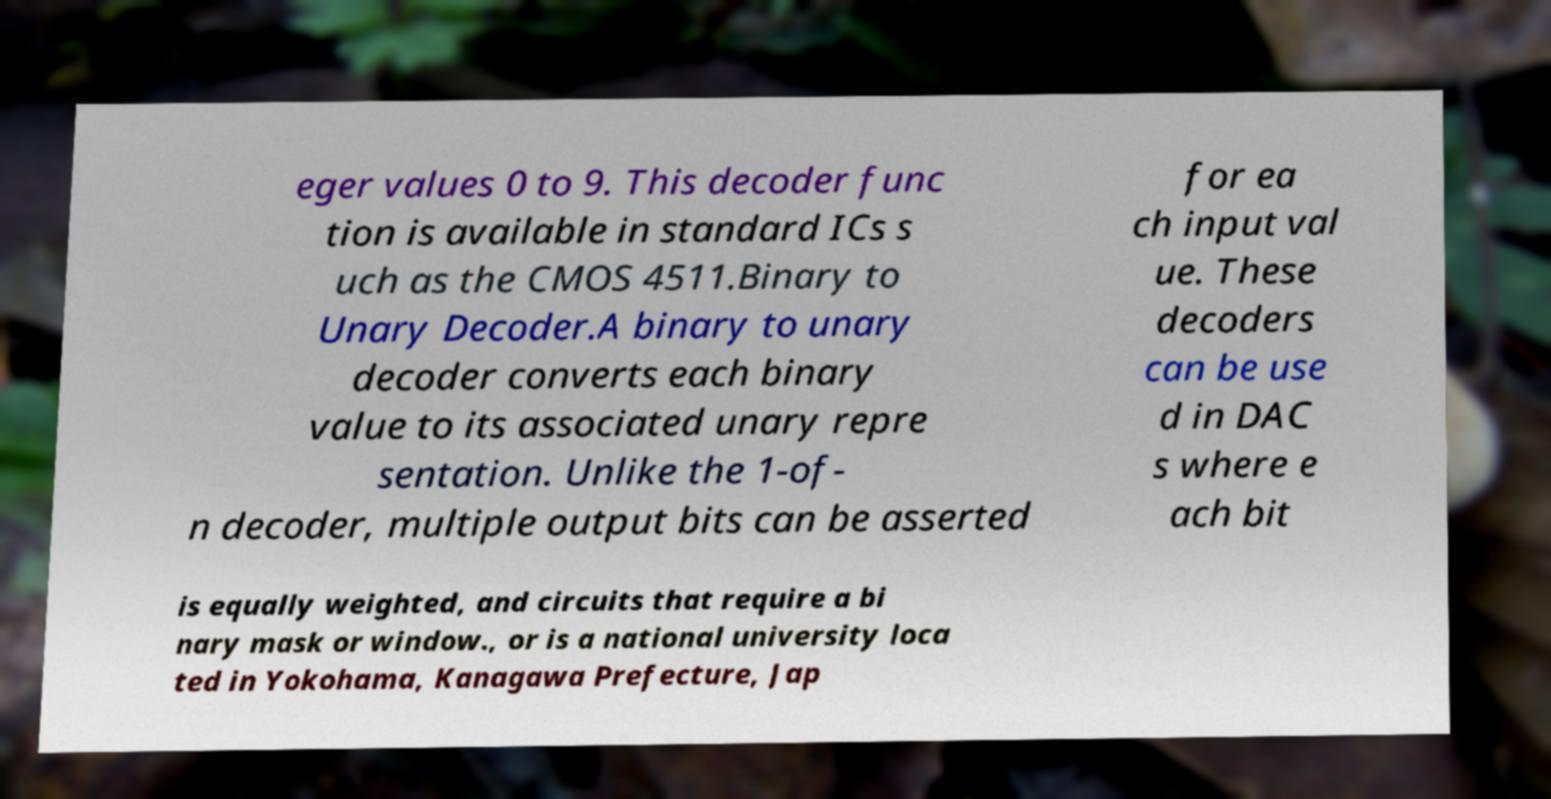What messages or text are displayed in this image? I need them in a readable, typed format. eger values 0 to 9. This decoder func tion is available in standard ICs s uch as the CMOS 4511.Binary to Unary Decoder.A binary to unary decoder converts each binary value to its associated unary repre sentation. Unlike the 1-of- n decoder, multiple output bits can be asserted for ea ch input val ue. These decoders can be use d in DAC s where e ach bit is equally weighted, and circuits that require a bi nary mask or window., or is a national university loca ted in Yokohama, Kanagawa Prefecture, Jap 